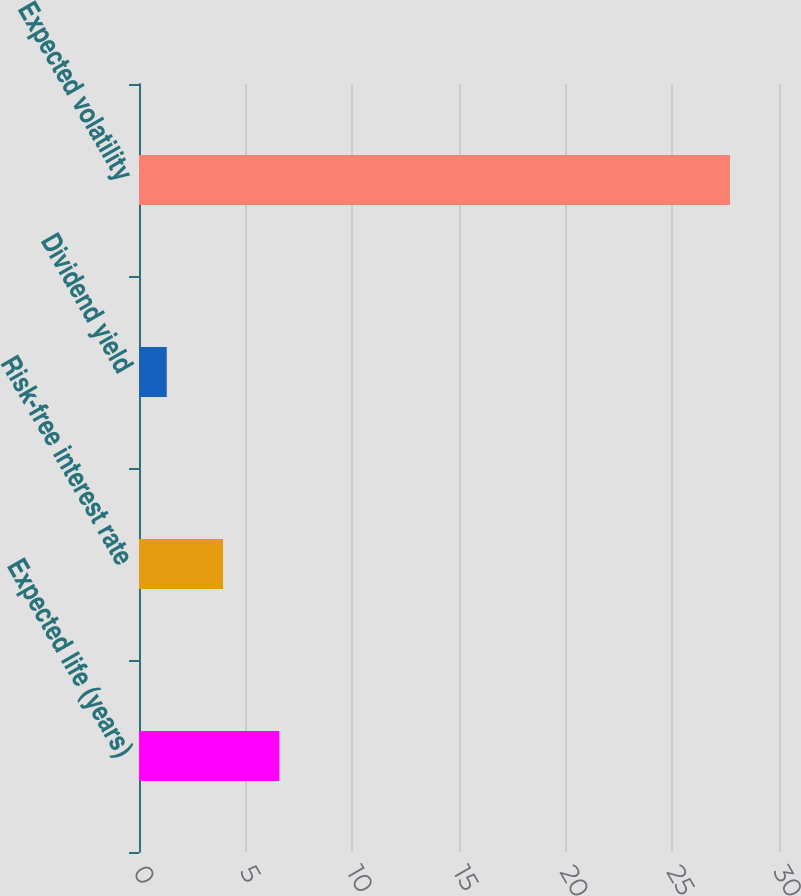Convert chart to OTSL. <chart><loc_0><loc_0><loc_500><loc_500><bar_chart><fcel>Expected life (years)<fcel>Risk-free interest rate<fcel>Dividend yield<fcel>Expected volatility<nl><fcel>6.58<fcel>3.94<fcel>1.3<fcel>27.7<nl></chart> 